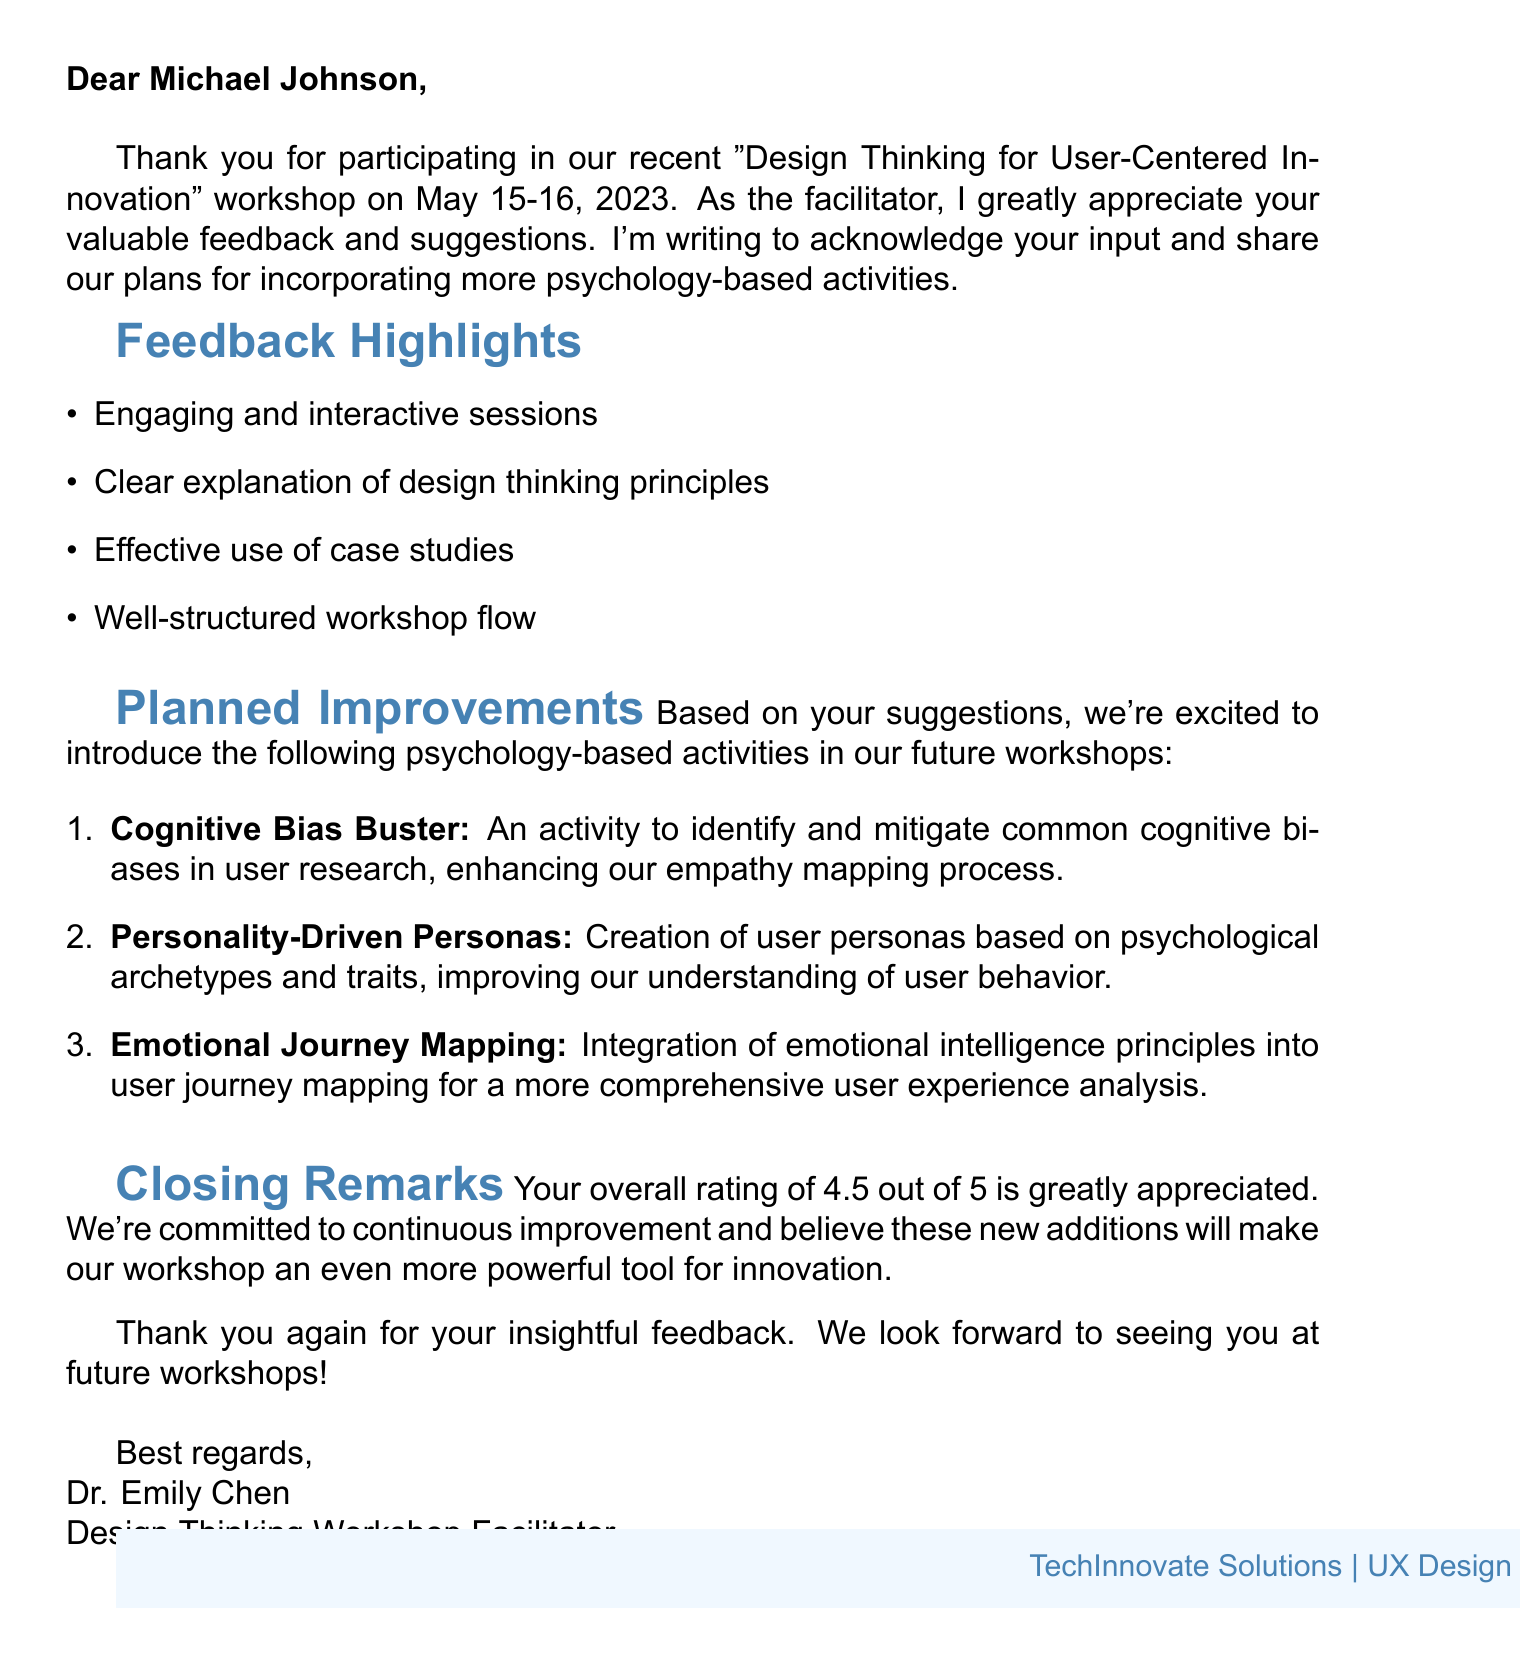what is the name of the workshop? The name of the workshop is stated in the document under workshop details.
Answer: Design Thinking for User-Centered Innovation who was the facilitator of the workshop? The facilitator's name is provided in the workshop details.
Answer: Dr. Emily Chen what is the overall rating given by the participant? The overall rating is found in the closing remarks section of the document.
Answer: 4.5 what were the dates of the workshop? The dates are clearly mentioned in the workshop details section.
Answer: May 15-16, 2023 what suggestion did the participant make regarding empathy mapping? This suggestion can be found in the suggested improvements section of the document.
Answer: Include cognitive bias exercises to improve empathy mapping what is one of the activities proposed to enhance understanding of user behavior? The activities are listed in the planned improvements section and require reasoning to combine user understanding with suggested improvements.
Answer: Personality-Driven Personas how many psychology activity ideas were presented? The number of ideas can be counted in the psychology activity ideas section of the document.
Answer: 3 what type of design professional was the participant? The participant's role is mentioned in the participant info section of the document.
Answer: UX Designer what aspect of the workshop did the participant find engaging? Information on engagement is located in the feedback highlights section.
Answer: Engaging and interactive sessions what is a proposed activity to boost creativity? The proposed activity is suggested in the planned improvements section.
Answer: Add mindfulness techniques to boost creativity and reduce cognitive overload 